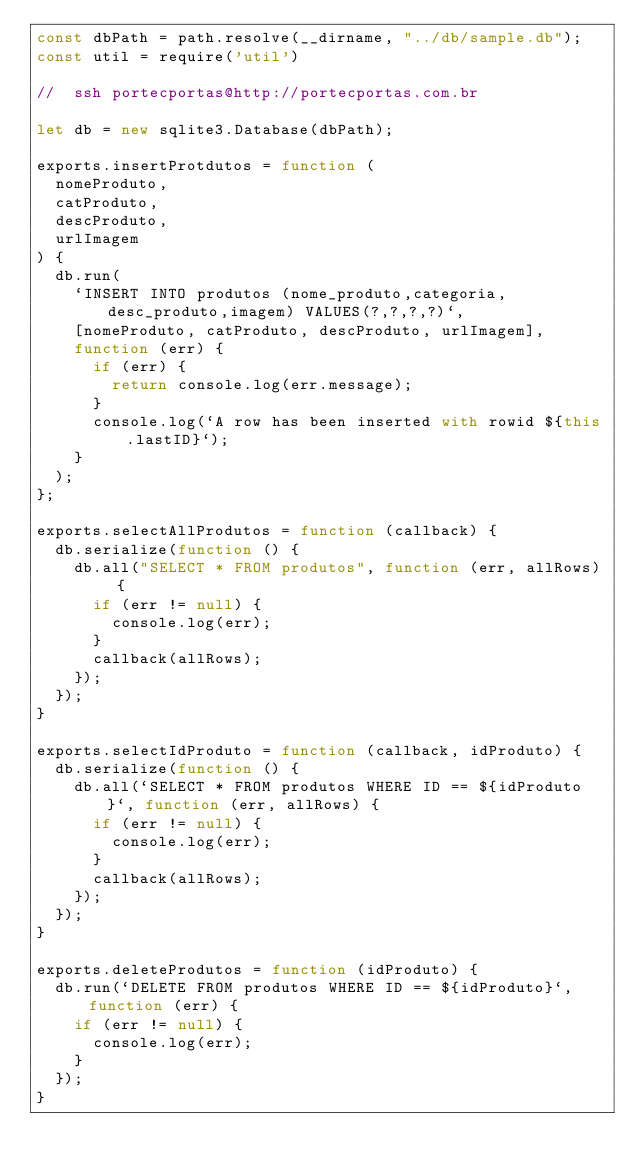Convert code to text. <code><loc_0><loc_0><loc_500><loc_500><_JavaScript_>const dbPath = path.resolve(__dirname, "../db/sample.db");
const util = require('util')

//  ssh portecportas@http://portecportas.com.br

let db = new sqlite3.Database(dbPath);

exports.insertProtdutos = function (
  nomeProduto,
  catProduto,
  descProduto,
  urlImagem
) {
  db.run(
    `INSERT INTO produtos (nome_produto,categoria,desc_produto,imagem) VALUES(?,?,?,?)`,
    [nomeProduto, catProduto, descProduto, urlImagem],
    function (err) {
      if (err) {
        return console.log(err.message);
      }
      console.log(`A row has been inserted with rowid ${this.lastID}`);
    }
  );
};

exports.selectAllProdutos = function (callback) {
  db.serialize(function () {
    db.all("SELECT * FROM produtos", function (err, allRows) {
      if (err != null) {
        console.log(err);
      }
      callback(allRows);
    });
  });
}

exports.selectIdProduto = function (callback, idProduto) {
  db.serialize(function () {
    db.all(`SELECT * FROM produtos WHERE ID == ${idProduto}`, function (err, allRows) {
      if (err != null) {
        console.log(err);
      }
      callback(allRows);
    });
  });
}

exports.deleteProdutos = function (idProduto) {
  db.run(`DELETE FROM produtos WHERE ID == ${idProduto}`, function (err) {
    if (err != null) {
      console.log(err);
    }
  });
}
</code> 